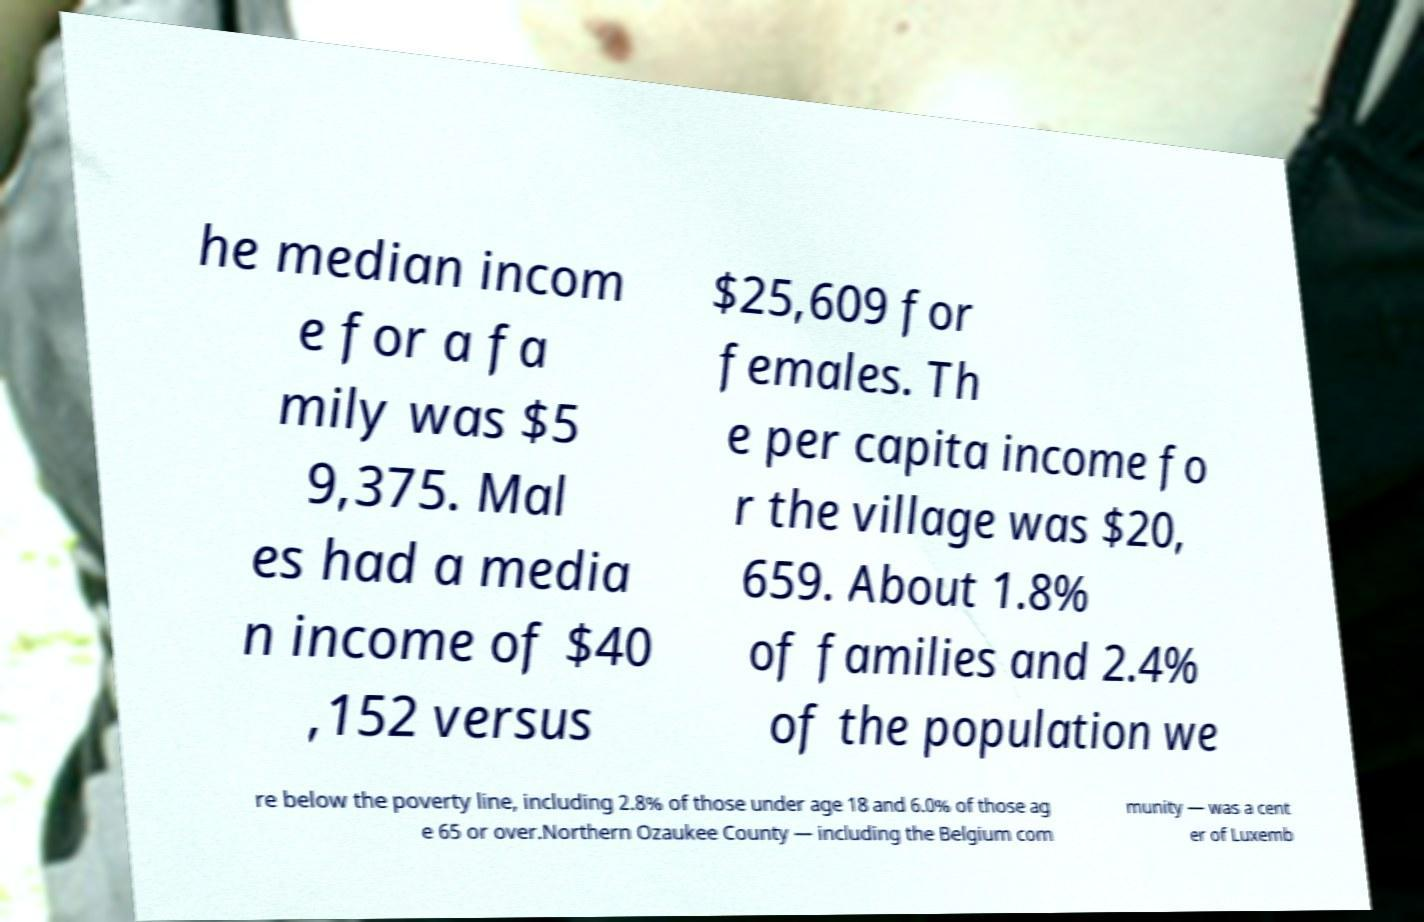Can you accurately transcribe the text from the provided image for me? he median incom e for a fa mily was $5 9,375. Mal es had a media n income of $40 ,152 versus $25,609 for females. Th e per capita income fo r the village was $20, 659. About 1.8% of families and 2.4% of the population we re below the poverty line, including 2.8% of those under age 18 and 6.0% of those ag e 65 or over.Northern Ozaukee County — including the Belgium com munity — was a cent er of Luxemb 